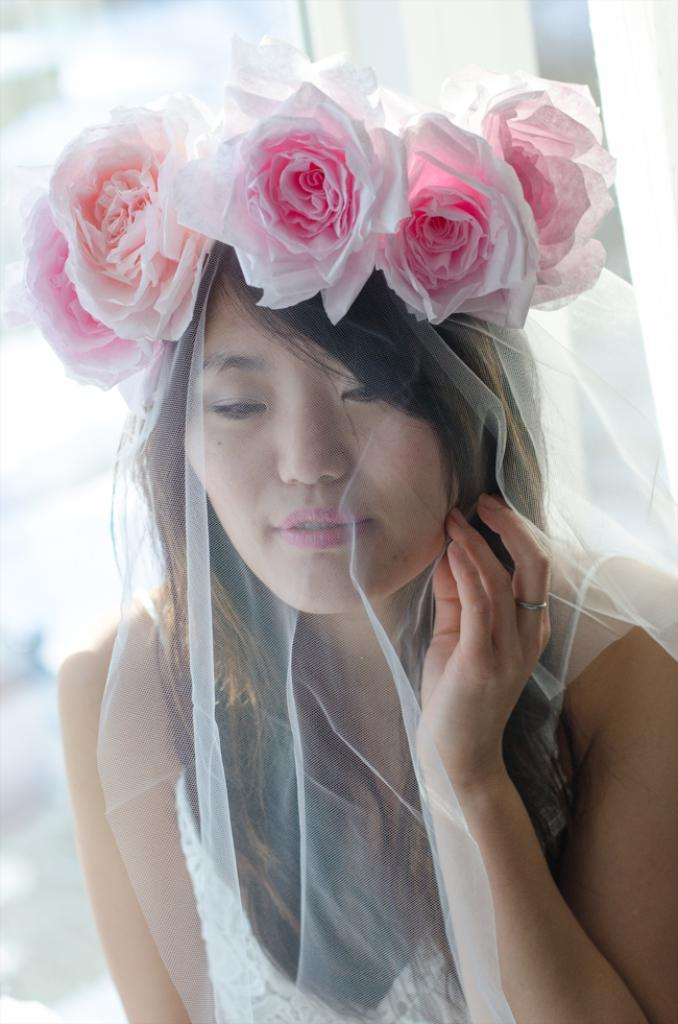Who is the main subject in the image? There is a woman in the image. What is the woman wearing? The woman is wearing a white dress. Are there any accessories or decorations on the woman? Yes, there are flowers on the woman's head. Can you describe the background of the image? The background of the image is blurred. What type of cork can be seen in the woman's hand in the image? There is no cork present in the image; the woman is not holding anything in her hand. 